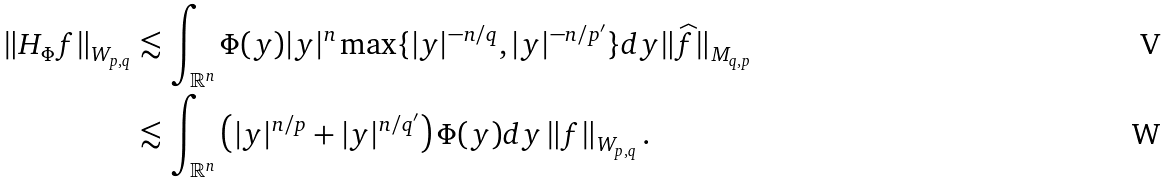<formula> <loc_0><loc_0><loc_500><loc_500>\| H _ { \Phi } f \| _ { W _ { p , q } } & \lesssim \int _ { \mathbb { R } ^ { n } } \Phi ( y ) | y | ^ { n } \max \{ | y | ^ { - n / q } , | y | ^ { - n / p ^ { \prime } } \} d y \| \widehat { f } \| _ { M _ { q , p } } \\ & \lesssim \int _ { \mathbb { R } ^ { n } } \left ( | y | ^ { n / { p } } + | y | ^ { n / q ^ { \prime } } \right ) \Phi ( y ) d y \left \| f \right \| _ { W _ { p , q } } .</formula> 